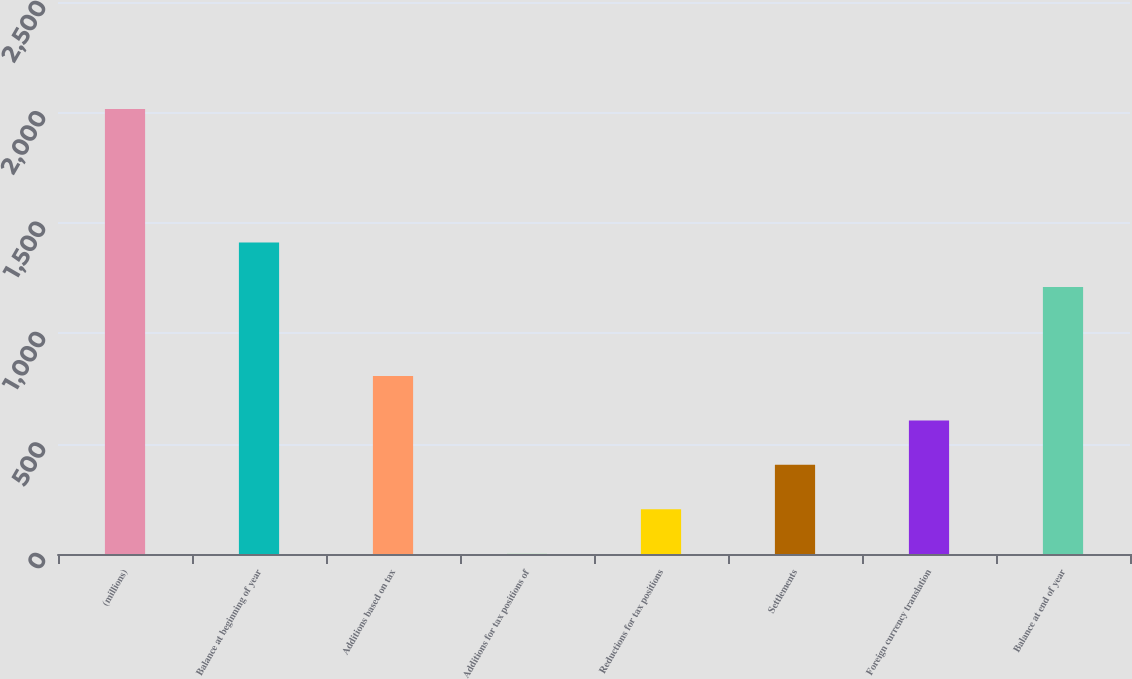Convert chart. <chart><loc_0><loc_0><loc_500><loc_500><bar_chart><fcel>(millions)<fcel>Balance at beginning of year<fcel>Additions based on tax<fcel>Additions for tax positions of<fcel>Reductions for tax positions<fcel>Settlements<fcel>Foreign currency translation<fcel>Balance at end of year<nl><fcel>2015<fcel>1410.77<fcel>806.54<fcel>0.9<fcel>202.31<fcel>403.72<fcel>605.13<fcel>1209.36<nl></chart> 